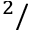Convert formula to latex. <formula><loc_0><loc_0><loc_500><loc_500>^ { 2 } /</formula> 